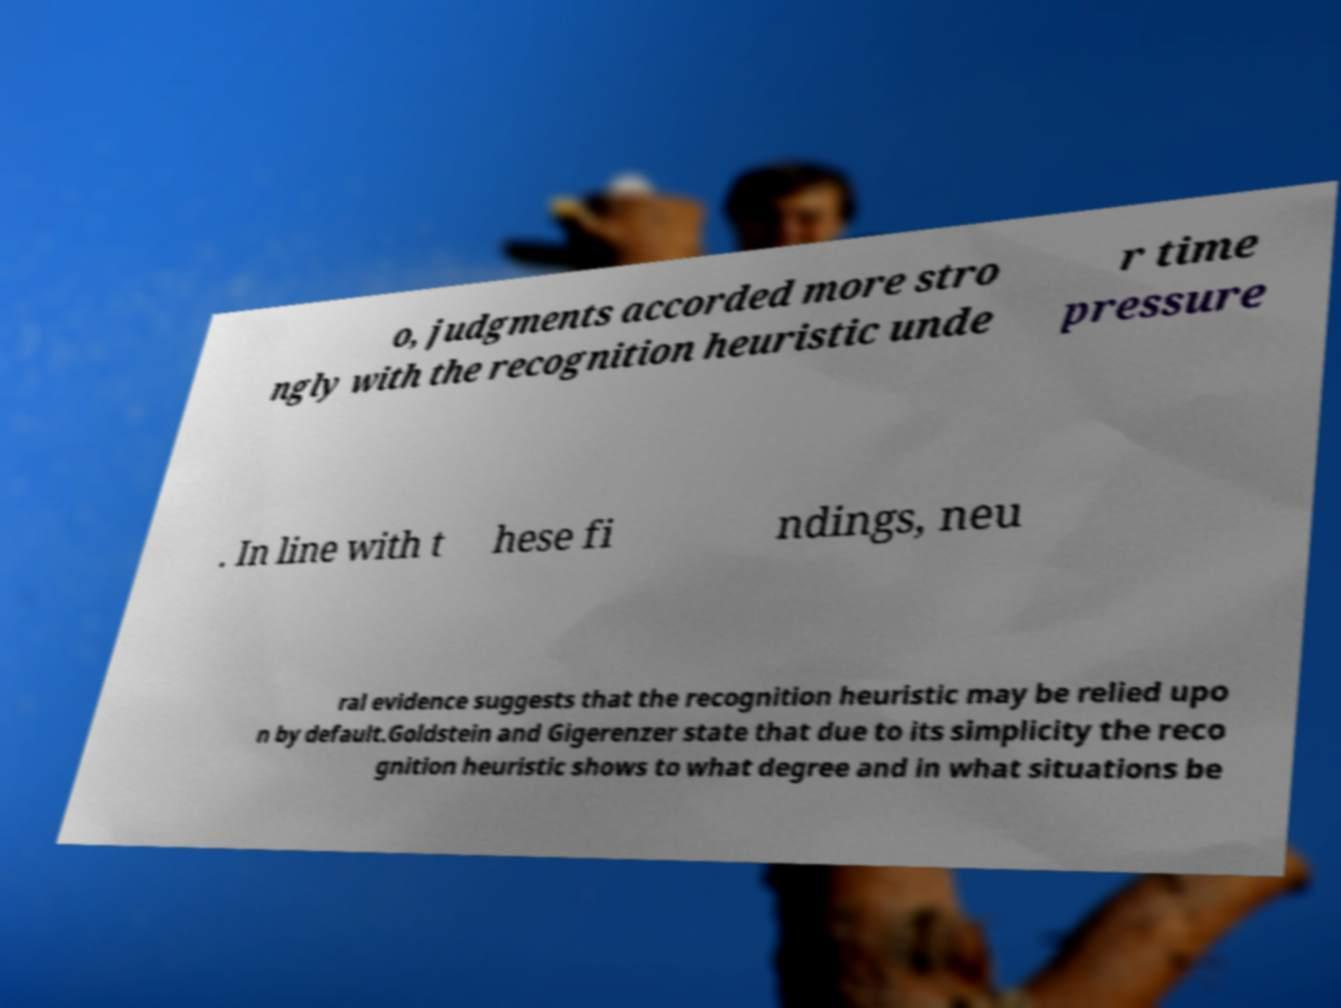Please identify and transcribe the text found in this image. o, judgments accorded more stro ngly with the recognition heuristic unde r time pressure . In line with t hese fi ndings, neu ral evidence suggests that the recognition heuristic may be relied upo n by default.Goldstein and Gigerenzer state that due to its simplicity the reco gnition heuristic shows to what degree and in what situations be 